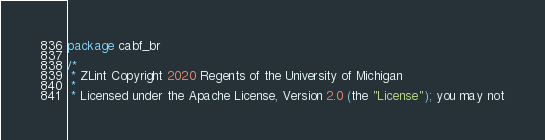<code> <loc_0><loc_0><loc_500><loc_500><_Go_>package cabf_br

/*
 * ZLint Copyright 2020 Regents of the University of Michigan
 *
 * Licensed under the Apache License, Version 2.0 (the "License"); you may not</code> 